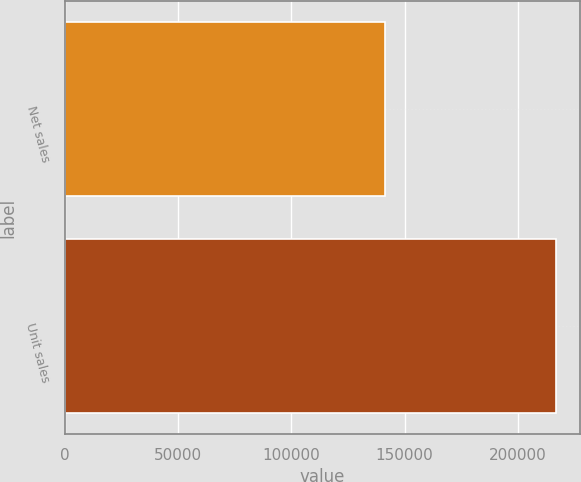Convert chart to OTSL. <chart><loc_0><loc_0><loc_500><loc_500><bar_chart><fcel>Net sales<fcel>Unit sales<nl><fcel>141319<fcel>216756<nl></chart> 